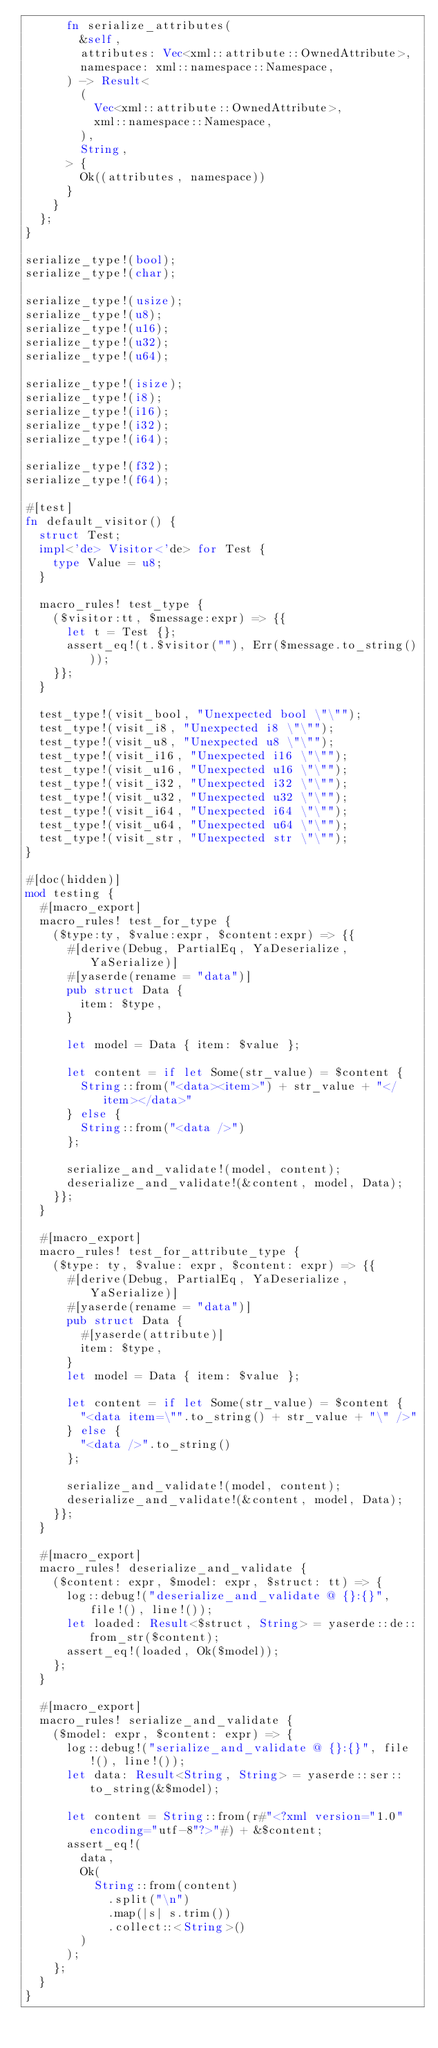Convert code to text. <code><loc_0><loc_0><loc_500><loc_500><_Rust_>      fn serialize_attributes(
        &self,
        attributes: Vec<xml::attribute::OwnedAttribute>,
        namespace: xml::namespace::Namespace,
      ) -> Result<
        (
          Vec<xml::attribute::OwnedAttribute>,
          xml::namespace::Namespace,
        ),
        String,
      > {
        Ok((attributes, namespace))
      }
    }
  };
}

serialize_type!(bool);
serialize_type!(char);

serialize_type!(usize);
serialize_type!(u8);
serialize_type!(u16);
serialize_type!(u32);
serialize_type!(u64);

serialize_type!(isize);
serialize_type!(i8);
serialize_type!(i16);
serialize_type!(i32);
serialize_type!(i64);

serialize_type!(f32);
serialize_type!(f64);

#[test]
fn default_visitor() {
  struct Test;
  impl<'de> Visitor<'de> for Test {
    type Value = u8;
  }

  macro_rules! test_type {
    ($visitor:tt, $message:expr) => {{
      let t = Test {};
      assert_eq!(t.$visitor(""), Err($message.to_string()));
    }};
  }

  test_type!(visit_bool, "Unexpected bool \"\"");
  test_type!(visit_i8, "Unexpected i8 \"\"");
  test_type!(visit_u8, "Unexpected u8 \"\"");
  test_type!(visit_i16, "Unexpected i16 \"\"");
  test_type!(visit_u16, "Unexpected u16 \"\"");
  test_type!(visit_i32, "Unexpected i32 \"\"");
  test_type!(visit_u32, "Unexpected u32 \"\"");
  test_type!(visit_i64, "Unexpected i64 \"\"");
  test_type!(visit_u64, "Unexpected u64 \"\"");
  test_type!(visit_str, "Unexpected str \"\"");
}

#[doc(hidden)]
mod testing {
  #[macro_export]
  macro_rules! test_for_type {
    ($type:ty, $value:expr, $content:expr) => {{
      #[derive(Debug, PartialEq, YaDeserialize, YaSerialize)]
      #[yaserde(rename = "data")]
      pub struct Data {
        item: $type,
      }

      let model = Data { item: $value };

      let content = if let Some(str_value) = $content {
        String::from("<data><item>") + str_value + "</item></data>"
      } else {
        String::from("<data />")
      };

      serialize_and_validate!(model, content);
      deserialize_and_validate!(&content, model, Data);
    }};
  }

  #[macro_export]
  macro_rules! test_for_attribute_type {
    ($type: ty, $value: expr, $content: expr) => {{
      #[derive(Debug, PartialEq, YaDeserialize, YaSerialize)]
      #[yaserde(rename = "data")]
      pub struct Data {
        #[yaserde(attribute)]
        item: $type,
      }
      let model = Data { item: $value };

      let content = if let Some(str_value) = $content {
        "<data item=\"".to_string() + str_value + "\" />"
      } else {
        "<data />".to_string()
      };

      serialize_and_validate!(model, content);
      deserialize_and_validate!(&content, model, Data);
    }};
  }

  #[macro_export]
  macro_rules! deserialize_and_validate {
    ($content: expr, $model: expr, $struct: tt) => {
      log::debug!("deserialize_and_validate @ {}:{}", file!(), line!());
      let loaded: Result<$struct, String> = yaserde::de::from_str($content);
      assert_eq!(loaded, Ok($model));
    };
  }

  #[macro_export]
  macro_rules! serialize_and_validate {
    ($model: expr, $content: expr) => {
      log::debug!("serialize_and_validate @ {}:{}", file!(), line!());
      let data: Result<String, String> = yaserde::ser::to_string(&$model);

      let content = String::from(r#"<?xml version="1.0" encoding="utf-8"?>"#) + &$content;
      assert_eq!(
        data,
        Ok(
          String::from(content)
            .split("\n")
            .map(|s| s.trim())
            .collect::<String>()
        )
      );
    };
  }
}
</code> 